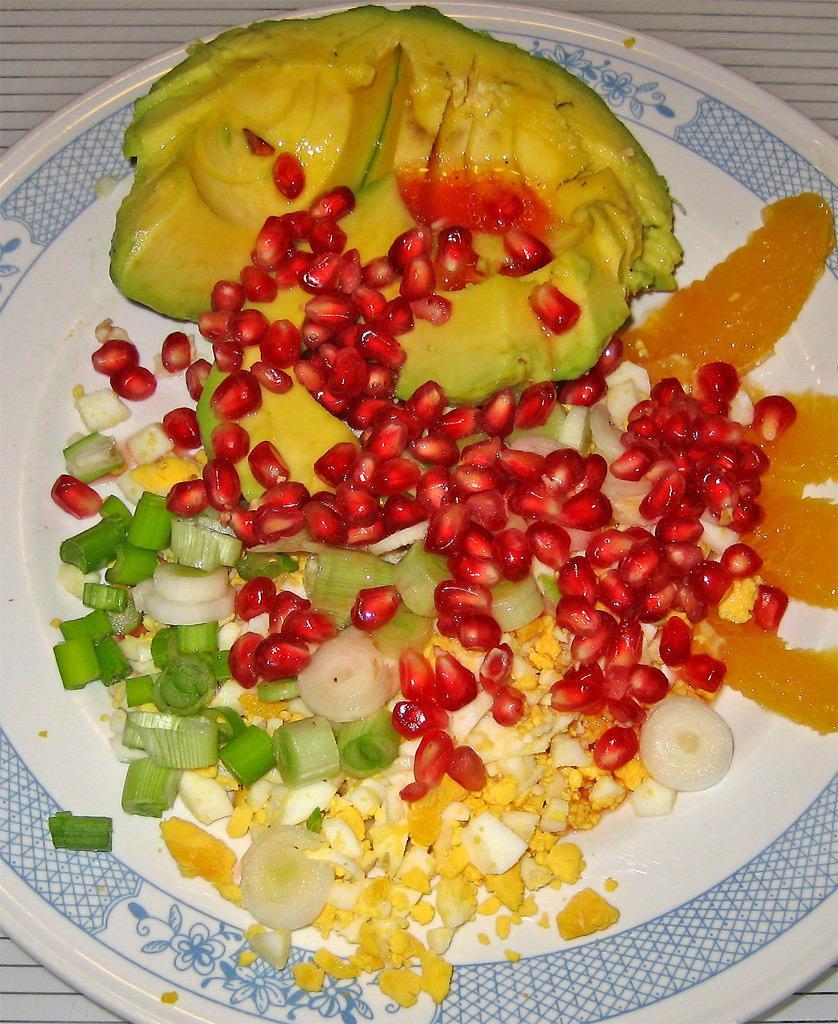In one or two sentences, can you explain what this image depicts? This image consists of a plate. There are pomegranate and herbs along with onions are kept on the plate. The plate is kept on the floor. 